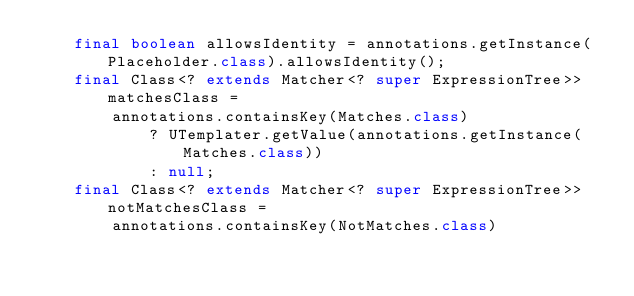Convert code to text. <code><loc_0><loc_0><loc_500><loc_500><_Java_>    final boolean allowsIdentity = annotations.getInstance(Placeholder.class).allowsIdentity();
    final Class<? extends Matcher<? super ExpressionTree>> matchesClass =
        annotations.containsKey(Matches.class)
            ? UTemplater.getValue(annotations.getInstance(Matches.class))
            : null;
    final Class<? extends Matcher<? super ExpressionTree>> notMatchesClass =
        annotations.containsKey(NotMatches.class)</code> 